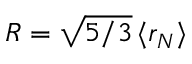<formula> <loc_0><loc_0><loc_500><loc_500>R = \sqrt { 5 / 3 } \, \langle r _ { N } \rangle</formula> 